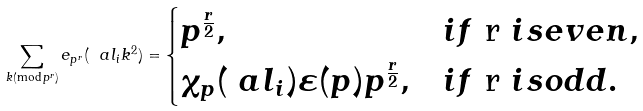Convert formula to latex. <formula><loc_0><loc_0><loc_500><loc_500>\sum _ { k ( \text {mod} \, p ^ { r } ) } e _ { p ^ { r } } ( \ a l _ { i } k ^ { 2 } ) = \begin{cases} p ^ { \frac { r } { 2 } } , & i f $ r $ i s e v e n , \\ \chi _ { p } ( \ a l _ { i } ) \varepsilon ( p ) p ^ { \frac { r } { 2 } } , & i f $ r $ i s o d d . \end{cases}</formula> 